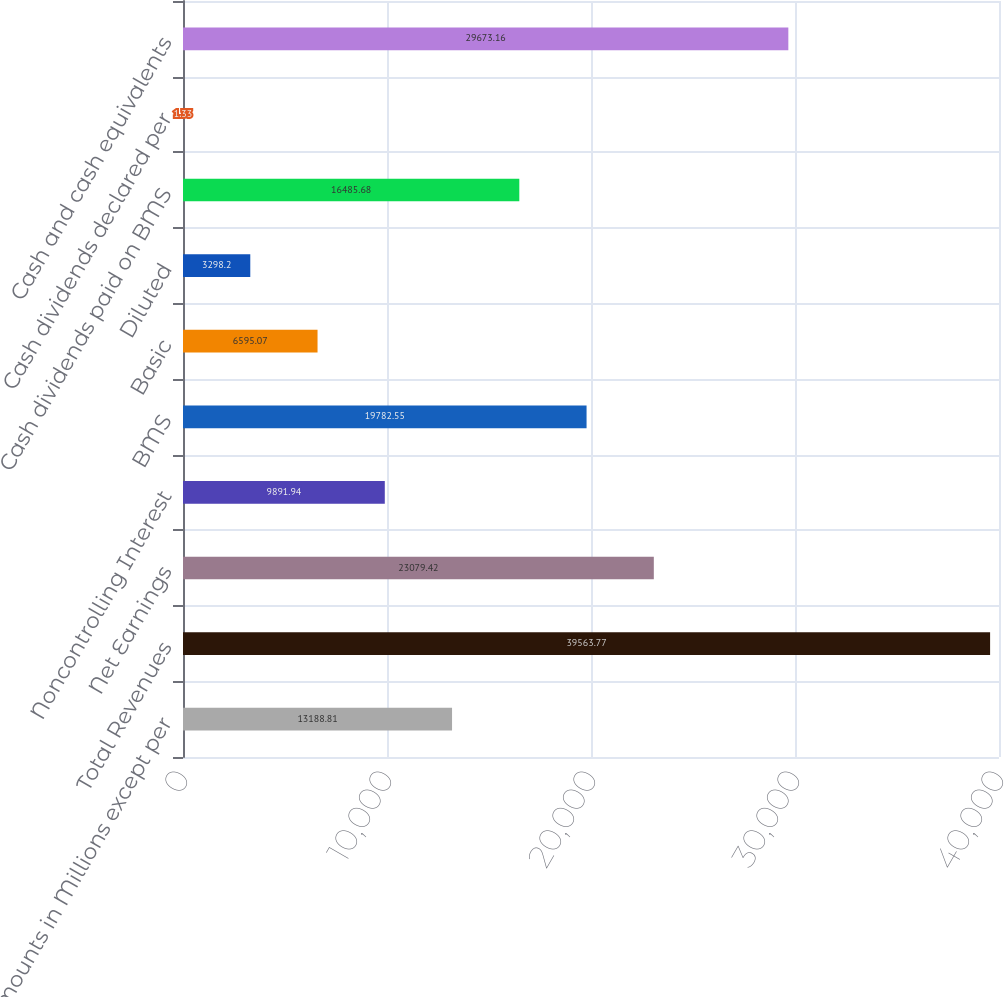<chart> <loc_0><loc_0><loc_500><loc_500><bar_chart><fcel>Amounts in Millions except per<fcel>Total Revenues<fcel>Net Earnings<fcel>Noncontrolling Interest<fcel>BMS<fcel>Basic<fcel>Diluted<fcel>Cash dividends paid on BMS<fcel>Cash dividends declared per<fcel>Cash and cash equivalents<nl><fcel>13188.8<fcel>39563.8<fcel>23079.4<fcel>9891.94<fcel>19782.5<fcel>6595.07<fcel>3298.2<fcel>16485.7<fcel>1.33<fcel>29673.2<nl></chart> 